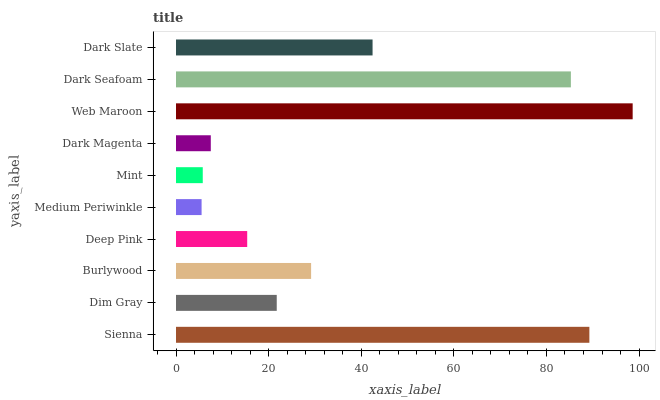Is Medium Periwinkle the minimum?
Answer yes or no. Yes. Is Web Maroon the maximum?
Answer yes or no. Yes. Is Dim Gray the minimum?
Answer yes or no. No. Is Dim Gray the maximum?
Answer yes or no. No. Is Sienna greater than Dim Gray?
Answer yes or no. Yes. Is Dim Gray less than Sienna?
Answer yes or no. Yes. Is Dim Gray greater than Sienna?
Answer yes or no. No. Is Sienna less than Dim Gray?
Answer yes or no. No. Is Burlywood the high median?
Answer yes or no. Yes. Is Dim Gray the low median?
Answer yes or no. Yes. Is Sienna the high median?
Answer yes or no. No. Is Sienna the low median?
Answer yes or no. No. 